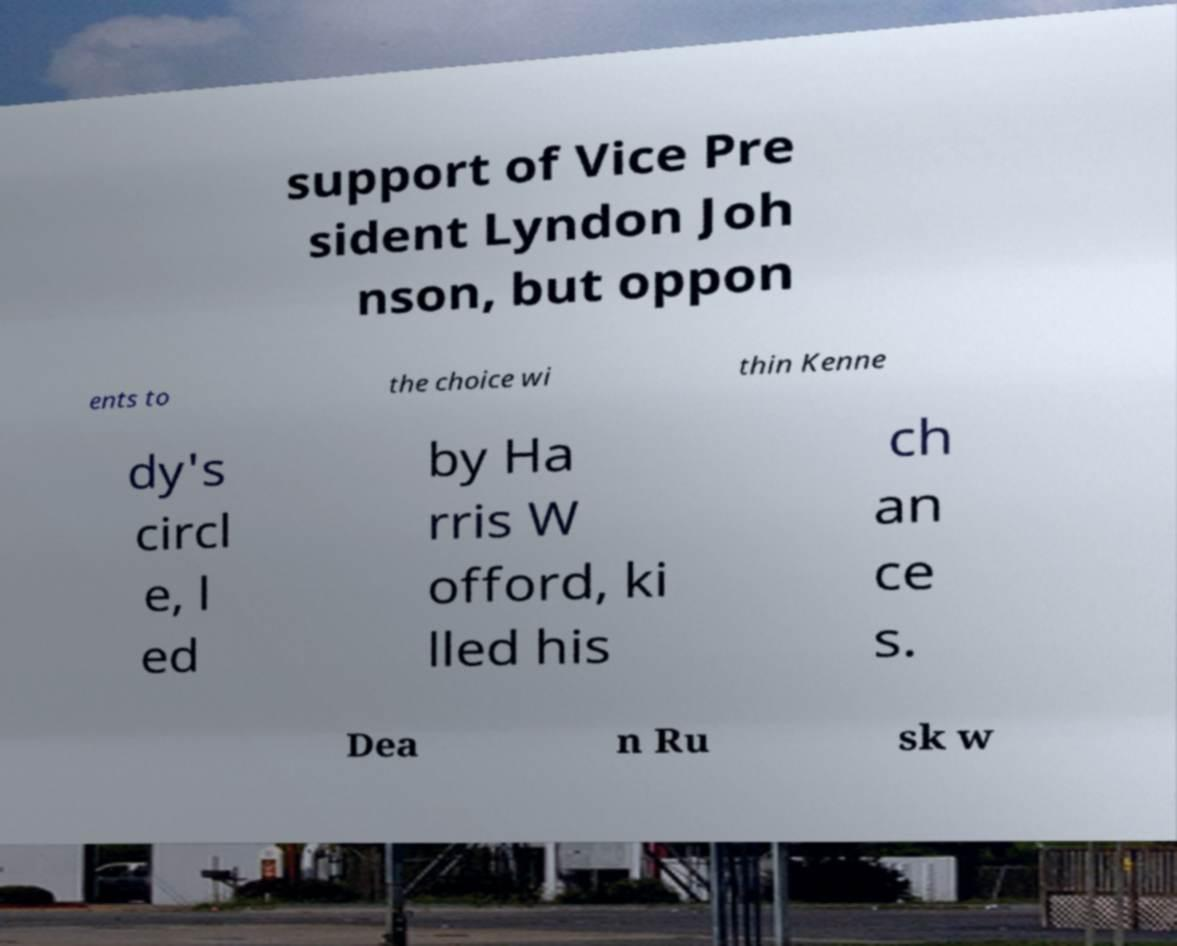Can you read and provide the text displayed in the image?This photo seems to have some interesting text. Can you extract and type it out for me? support of Vice Pre sident Lyndon Joh nson, but oppon ents to the choice wi thin Kenne dy's circl e, l ed by Ha rris W offord, ki lled his ch an ce s. Dea n Ru sk w 